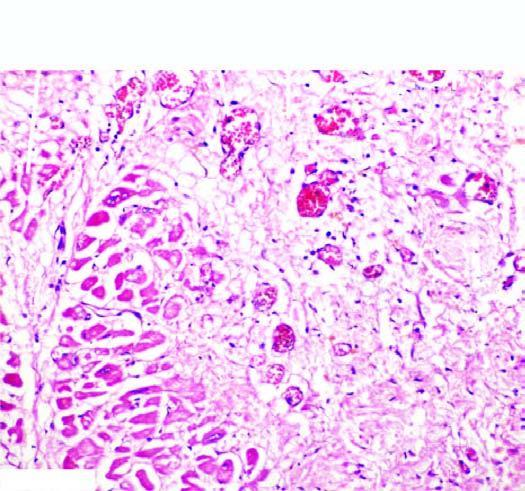does the peripheral zone show ingrowth of inflammatory granulation tissue?
Answer the question using a single word or phrase. No 